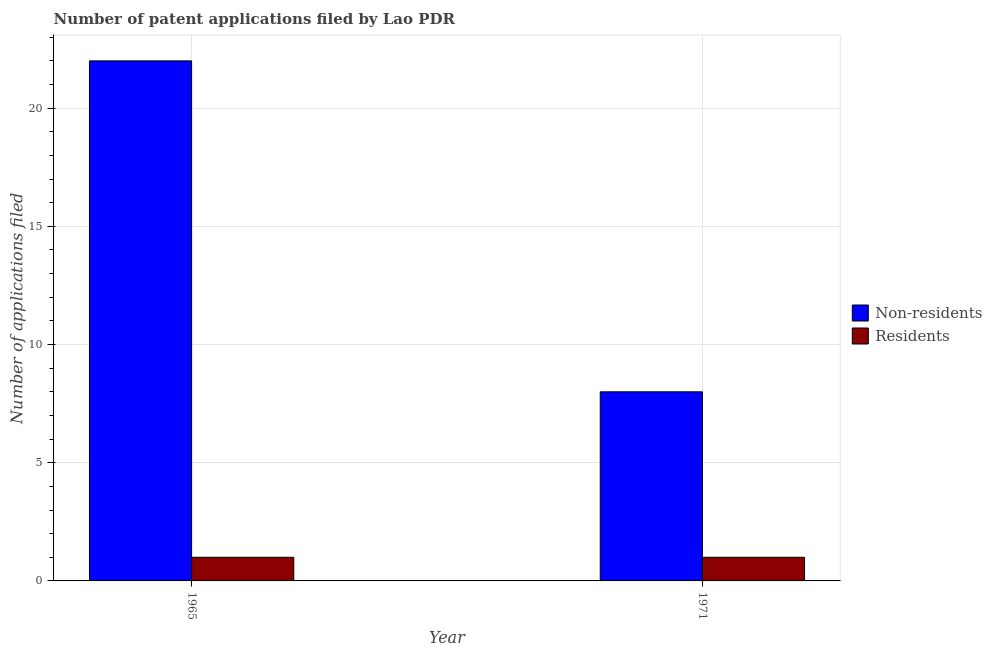How many different coloured bars are there?
Provide a succinct answer. 2. How many groups of bars are there?
Keep it short and to the point. 2. Are the number of bars per tick equal to the number of legend labels?
Offer a very short reply. Yes. What is the label of the 2nd group of bars from the left?
Give a very brief answer. 1971. In how many cases, is the number of bars for a given year not equal to the number of legend labels?
Offer a terse response. 0. What is the number of patent applications by residents in 1971?
Offer a very short reply. 1. Across all years, what is the maximum number of patent applications by residents?
Your answer should be very brief. 1. Across all years, what is the minimum number of patent applications by non residents?
Offer a terse response. 8. In which year was the number of patent applications by non residents maximum?
Provide a short and direct response. 1965. In which year was the number of patent applications by non residents minimum?
Your answer should be very brief. 1971. What is the total number of patent applications by residents in the graph?
Provide a short and direct response. 2. What is the difference between the number of patent applications by non residents in 1965 and that in 1971?
Your response must be concise. 14. What is the difference between the number of patent applications by residents in 1971 and the number of patent applications by non residents in 1965?
Provide a succinct answer. 0. In the year 1965, what is the difference between the number of patent applications by residents and number of patent applications by non residents?
Keep it short and to the point. 0. In how many years, is the number of patent applications by non residents greater than 22?
Make the answer very short. 0. What is the ratio of the number of patent applications by residents in 1965 to that in 1971?
Offer a terse response. 1. Is the number of patent applications by residents in 1965 less than that in 1971?
Your answer should be very brief. No. In how many years, is the number of patent applications by residents greater than the average number of patent applications by residents taken over all years?
Give a very brief answer. 0. What does the 2nd bar from the left in 1965 represents?
Offer a terse response. Residents. What does the 1st bar from the right in 1965 represents?
Your response must be concise. Residents. How many bars are there?
Keep it short and to the point. 4. Are all the bars in the graph horizontal?
Offer a very short reply. No. How many years are there in the graph?
Make the answer very short. 2. What is the difference between two consecutive major ticks on the Y-axis?
Provide a short and direct response. 5. Where does the legend appear in the graph?
Provide a succinct answer. Center right. How are the legend labels stacked?
Your answer should be compact. Vertical. What is the title of the graph?
Your response must be concise. Number of patent applications filed by Lao PDR. Does "Tetanus" appear as one of the legend labels in the graph?
Your answer should be compact. No. What is the label or title of the Y-axis?
Provide a short and direct response. Number of applications filed. What is the Number of applications filed in Residents in 1965?
Offer a very short reply. 1. What is the Number of applications filed in Non-residents in 1971?
Provide a short and direct response. 8. What is the Number of applications filed of Residents in 1971?
Ensure brevity in your answer.  1. What is the difference between the Number of applications filed of Non-residents in 1965 and that in 1971?
Your answer should be very brief. 14. What is the difference between the Number of applications filed in Residents in 1965 and that in 1971?
Make the answer very short. 0. What is the average Number of applications filed in Non-residents per year?
Make the answer very short. 15. In the year 1965, what is the difference between the Number of applications filed of Non-residents and Number of applications filed of Residents?
Your answer should be compact. 21. What is the ratio of the Number of applications filed in Non-residents in 1965 to that in 1971?
Offer a terse response. 2.75. What is the ratio of the Number of applications filed of Residents in 1965 to that in 1971?
Offer a terse response. 1. 